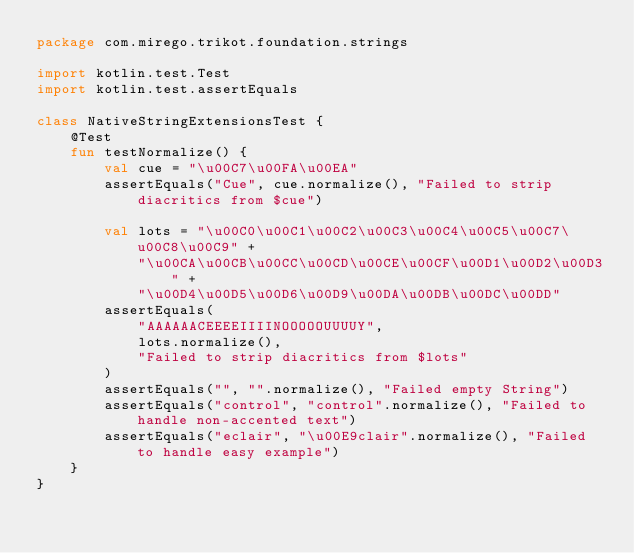<code> <loc_0><loc_0><loc_500><loc_500><_Kotlin_>package com.mirego.trikot.foundation.strings

import kotlin.test.Test
import kotlin.test.assertEquals

class NativeStringExtensionsTest {
    @Test
    fun testNormalize() {
        val cue = "\u00C7\u00FA\u00EA"
        assertEquals("Cue", cue.normalize(), "Failed to strip diacritics from $cue")

        val lots = "\u00C0\u00C1\u00C2\u00C3\u00C4\u00C5\u00C7\u00C8\u00C9" +
            "\u00CA\u00CB\u00CC\u00CD\u00CE\u00CF\u00D1\u00D2\u00D3" +
            "\u00D4\u00D5\u00D6\u00D9\u00DA\u00DB\u00DC\u00DD"
        assertEquals(
            "AAAAAACEEEEIIIINOOOOOUUUUY",
            lots.normalize(),
            "Failed to strip diacritics from $lots"
        )
        assertEquals("", "".normalize(), "Failed empty String")
        assertEquals("control", "control".normalize(), "Failed to handle non-accented text")
        assertEquals("eclair", "\u00E9clair".normalize(), "Failed to handle easy example")
    }
}
</code> 